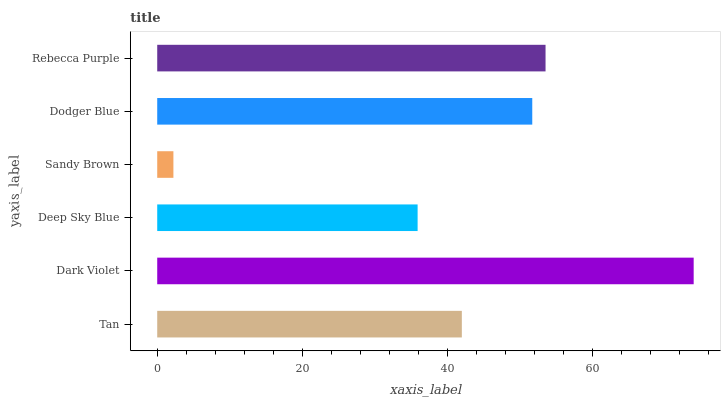Is Sandy Brown the minimum?
Answer yes or no. Yes. Is Dark Violet the maximum?
Answer yes or no. Yes. Is Deep Sky Blue the minimum?
Answer yes or no. No. Is Deep Sky Blue the maximum?
Answer yes or no. No. Is Dark Violet greater than Deep Sky Blue?
Answer yes or no. Yes. Is Deep Sky Blue less than Dark Violet?
Answer yes or no. Yes. Is Deep Sky Blue greater than Dark Violet?
Answer yes or no. No. Is Dark Violet less than Deep Sky Blue?
Answer yes or no. No. Is Dodger Blue the high median?
Answer yes or no. Yes. Is Tan the low median?
Answer yes or no. Yes. Is Tan the high median?
Answer yes or no. No. Is Rebecca Purple the low median?
Answer yes or no. No. 